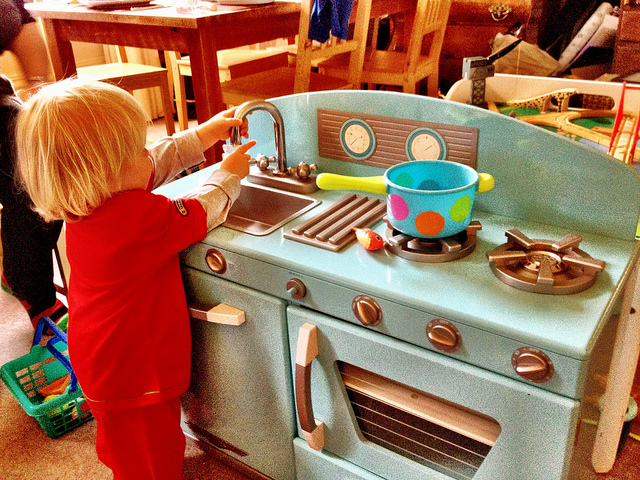Which meal might the child be pretending to cook on their stove? Judging by the imaginative setup, the child might be pretending to cook a delightful breakfast, perhaps pancakes or eggs, something common for a playful kitchen scenario like this one. 